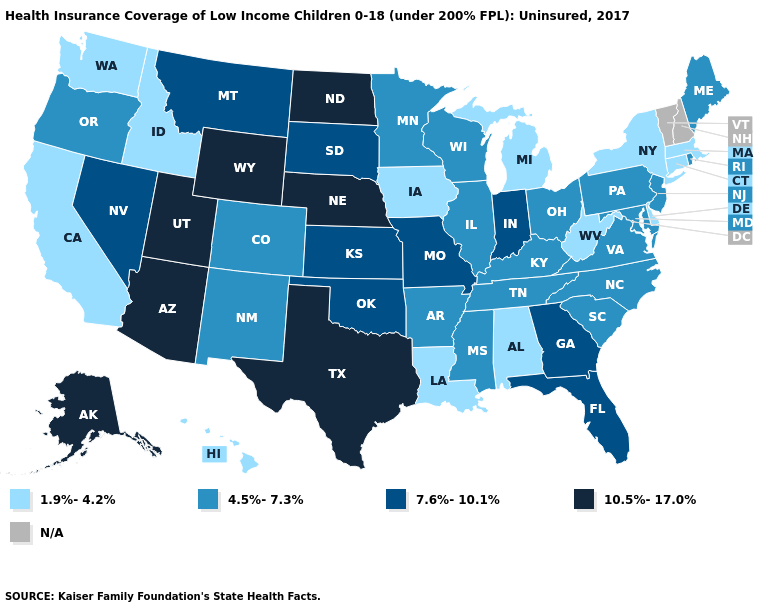What is the value of Alabama?
Quick response, please. 1.9%-4.2%. What is the value of Maine?
Write a very short answer. 4.5%-7.3%. Does Pennsylvania have the highest value in the Northeast?
Answer briefly. Yes. What is the value of Maine?
Quick response, please. 4.5%-7.3%. What is the highest value in the West ?
Be succinct. 10.5%-17.0%. What is the value of Texas?
Write a very short answer. 10.5%-17.0%. What is the lowest value in the USA?
Quick response, please. 1.9%-4.2%. Name the states that have a value in the range N/A?
Write a very short answer. New Hampshire, Vermont. Is the legend a continuous bar?
Keep it brief. No. Among the states that border California , does Oregon have the highest value?
Write a very short answer. No. Does Oklahoma have the lowest value in the South?
Concise answer only. No. Name the states that have a value in the range 10.5%-17.0%?
Concise answer only. Alaska, Arizona, Nebraska, North Dakota, Texas, Utah, Wyoming. What is the highest value in the South ?
Answer briefly. 10.5%-17.0%. Name the states that have a value in the range 10.5%-17.0%?
Short answer required. Alaska, Arizona, Nebraska, North Dakota, Texas, Utah, Wyoming. 